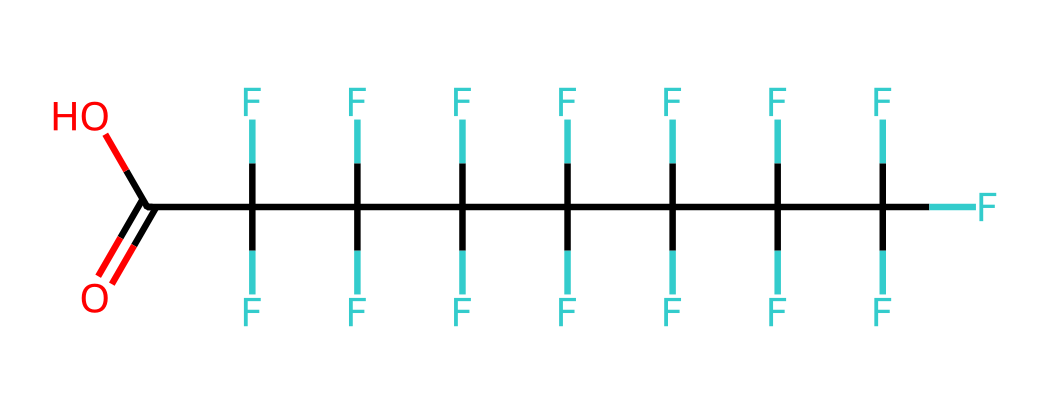What is the name of the chemical represented by this SMILES? The SMILES provided indicates a chemical structure characterized by a long chain of carbon atoms and several fluorine atoms attached to them, culminating in a carboxylic acid group, which identifies it as perfluorooctanoic acid.
Answer: perfluorooctanoic acid How many carbon atoms are in perfluorooctanoic acid? By analyzing the structure derived from the SMILES representation, we can count 8 carbon atoms present, indicating the base of the perfluorinated octanoic acid.
Answer: 8 What functional group is found in perfluorooctanoic acid? The chemical structure shows the presence of a carboxylic acid functional group (indicated by the -COOH), distinguishing it from other fluorinated compounds.
Answer: carboxylic acid How many fluorine atoms are in perfluorooctanoic acid? The structure reveals that there are 17 fluorine atoms attached to the carbons along the chain, revealing the perfluorinated nature of the compound.
Answer: 17 Is perfluorooctanoic acid considered toxic? Research and regulatory bodies classify perfluorooctanoic acid as a toxic chemical due to its persistence in the environment and potential health effects.
Answer: yes Which property of perfluorooctanoic acid contributes to its water-resistant applications? The high degree of fluorination makes perfluorooctanoic acid lipophobic and hydrophobic, providing water and stain resistance in materials like hockey jerseys.
Answer: hydrophobic 